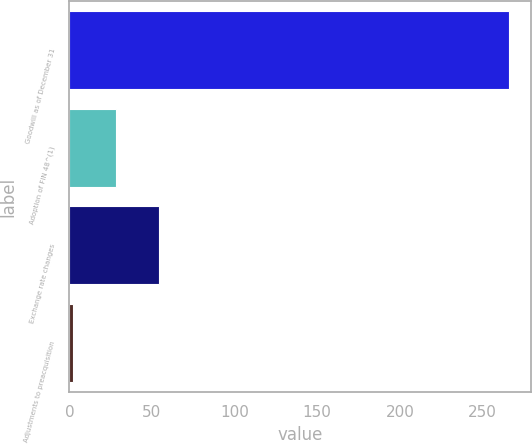Convert chart to OTSL. <chart><loc_0><loc_0><loc_500><loc_500><bar_chart><fcel>Goodwill as of December 31<fcel>Adoption of FIN 48^(1)<fcel>Exchange rate changes<fcel>Adjustments to preacquisition<nl><fcel>266.2<fcel>28.2<fcel>54.4<fcel>2<nl></chart> 